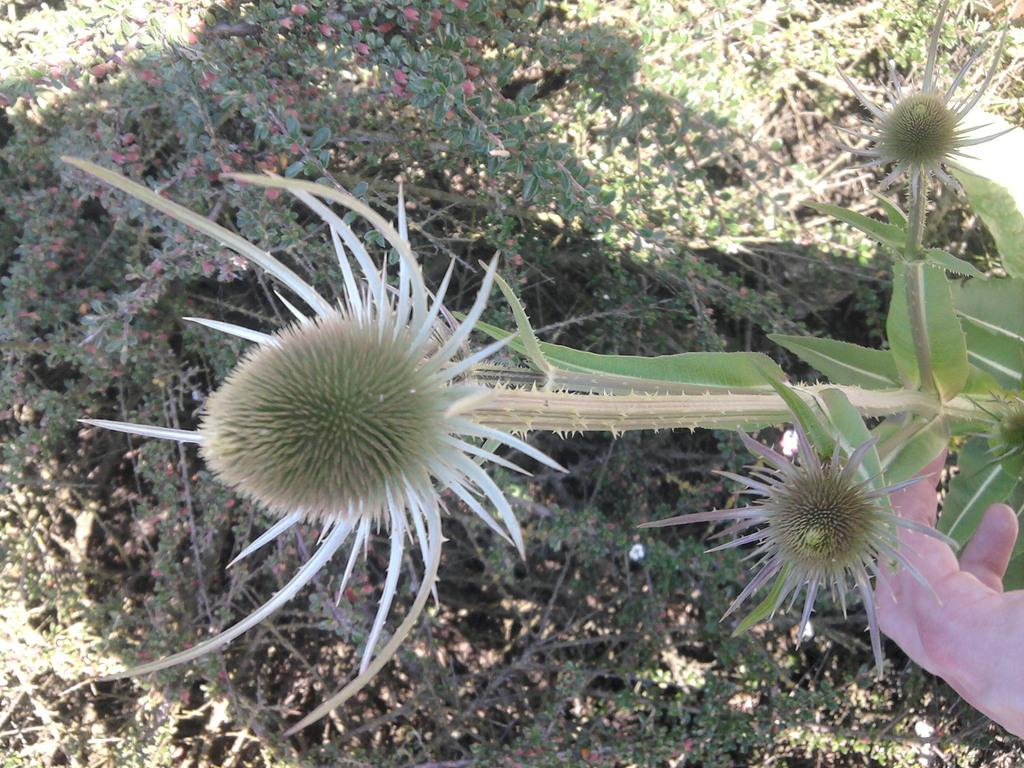What type of plant is present in the image? There is a flower plant in the image. What can be observed on the flower plant? The flower plant has flowers. Whose hand is visible in the image? There is a person's hand visible in the image. What other plants are present in the image besides the flower plant? There are other plants in the image. What type of flag is being waved by the flower plant in the image? There is no flag present in the image; it features a flower plant and other plants. Where is the basin located in the image? There is no basin present in the image. 